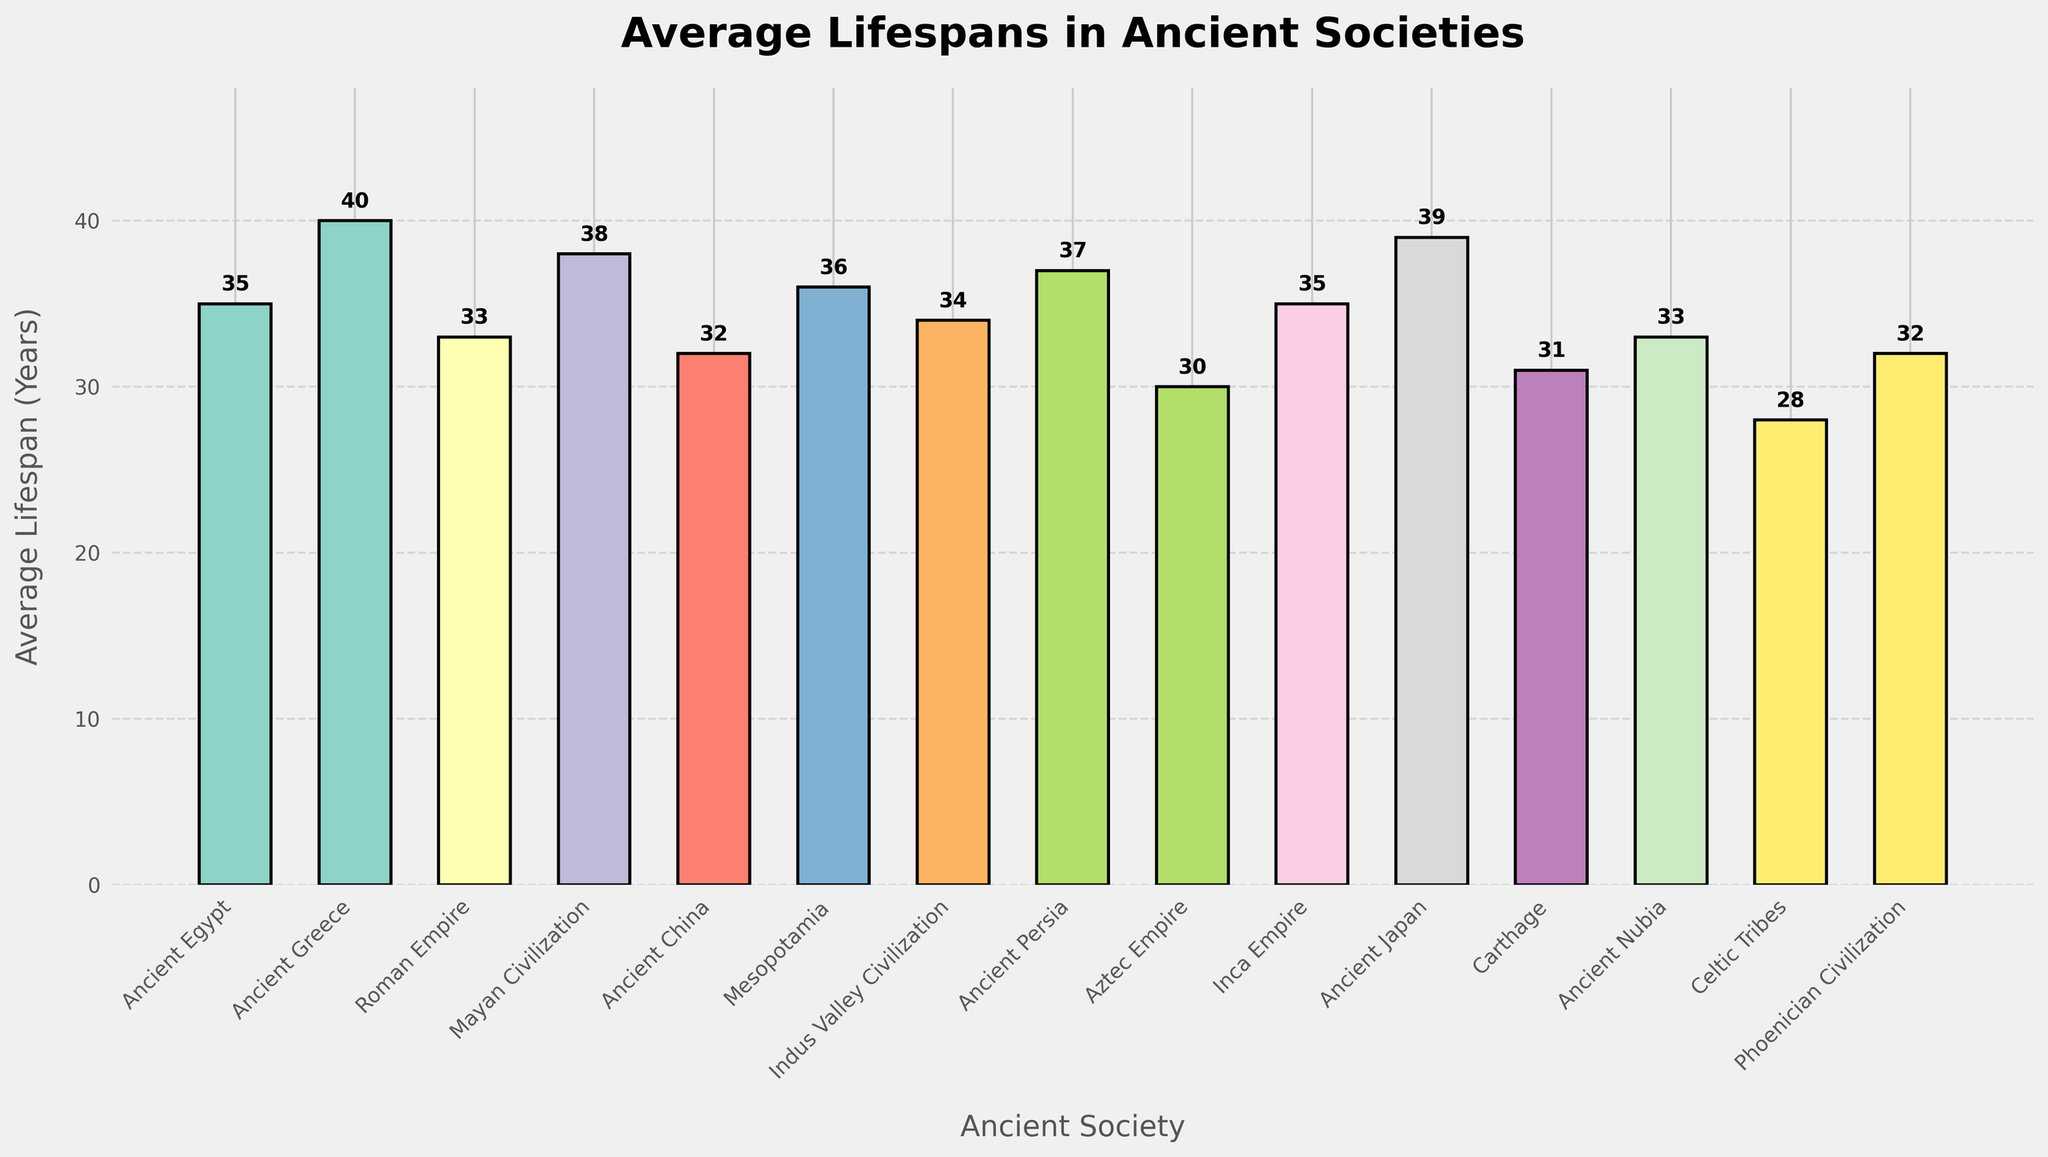Which society has the highest average lifespan? Look for the tallest bar in the chart, which represents the highest value.
Answer: Ancient Greece Which society has the lowest average lifespan? Look for the shortest bar in the chart, which represents the lowest value.
Answer: Celtic Tribes How much longer was the average lifespan in Ancient Greece compared to the Celtic Tribes? Subtract the average lifespan of the Celtic Tribes from the average lifespan of Ancient Greece (40 - 28).
Answer: 12 years Which societies have an equal average lifespan of 35 years? Identify bars that reach the height corresponding to 35 years.
Answer: Ancient Egypt, Inca Empire How does the average lifespan in Ancient China compare to that of Mesopotamia? Compare the height of the bars for Ancient China and Mesopotamia.
Answer: Ancient China: 32 years, Mesopotamia: 36 years. Mesopotamia's average lifespan is 4 years longer What is the combined average lifespan of the societies with the top three highest lifespans? Identify the three tallest bars (Ancient Greece, Ancient Japan, Mayan Civilization) and sum their values (40 + 39 + 38).
Answer: 117 years Which society has an average lifespan closest to the overall average of all the societies shown? Calculate the overall average by summing all values and dividing by the number of societies, then find the society with the closest value.
Answer: Overall average: 34 years; Society closest: Indus Valley Civilization (34 years) How many societies have an average lifespan greater than 35 years? Count the bars that extend higher than the mark for 35 years.
Answer: 5 societies Which society has an average lifespan equal to the median value of lifespans shown? Order the lifespans and find the median, then identify the society corresponding to that median value.
Answer: Median value: 34 years; Society: Indus Valley Civilization 